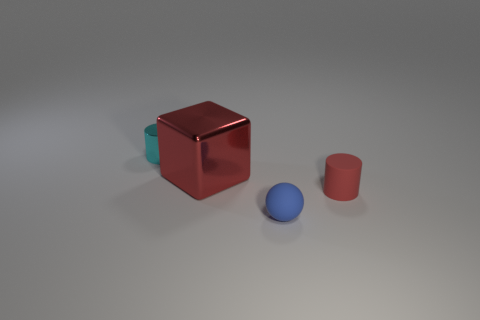Add 1 yellow shiny objects. How many objects exist? 5 Subtract all balls. How many objects are left? 3 Add 2 small matte spheres. How many small matte spheres exist? 3 Subtract 0 gray cubes. How many objects are left? 4 Subtract all cyan things. Subtract all tiny blue matte cylinders. How many objects are left? 3 Add 3 red cylinders. How many red cylinders are left? 4 